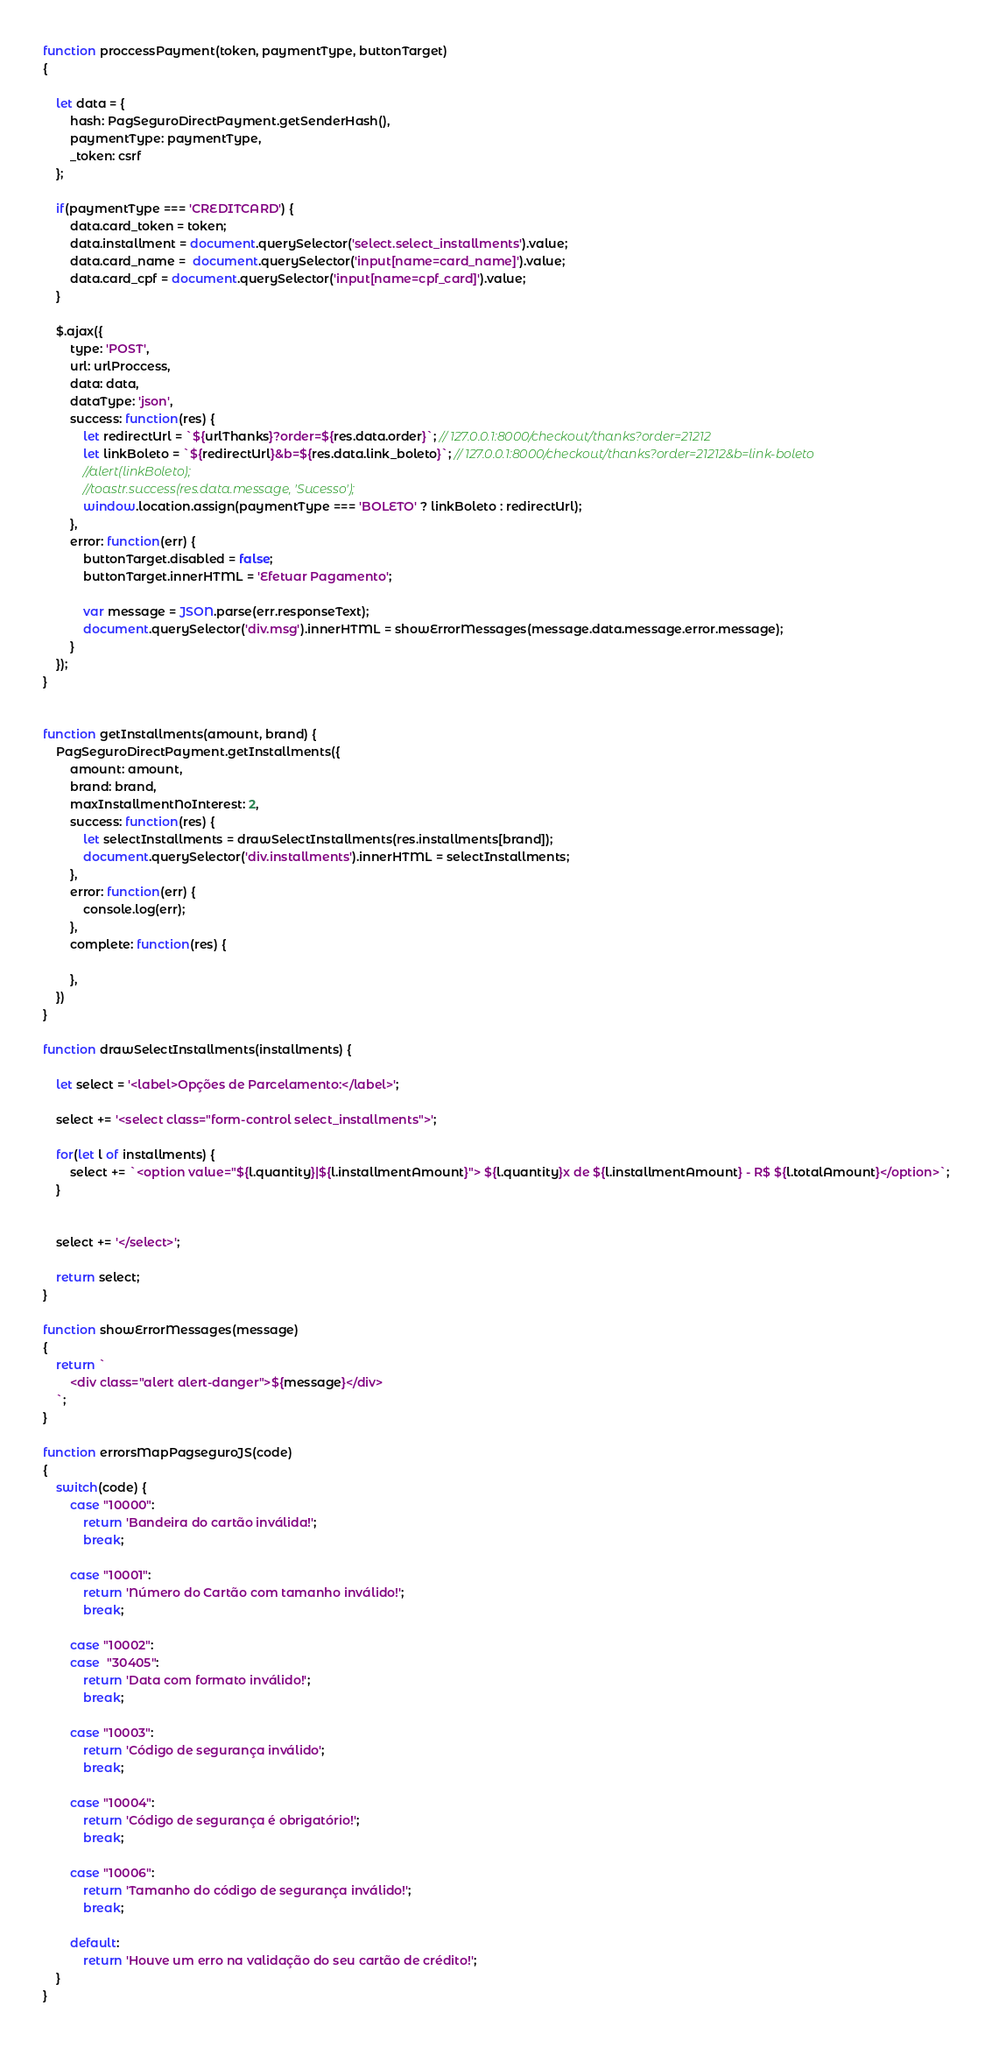Convert code to text. <code><loc_0><loc_0><loc_500><loc_500><_JavaScript_>function proccessPayment(token, paymentType, buttonTarget)
{
  
    let data = {
        hash: PagSeguroDirectPayment.getSenderHash(),
        paymentType: paymentType,
        _token: csrf
    };

    if(paymentType === 'CREDITCARD') {
        data.card_token = token;
        data.installment = document.querySelector('select.select_installments').value;
        data.card_name =  document.querySelector('input[name=card_name]').value;
        data.card_cpf = document.querySelector('input[name=cpf_card]').value;
    }

    $.ajax({
        type: 'POST',
        url: urlProccess,
        data: data,
        dataType: 'json',
        success: function(res) { 
            let redirectUrl = `${urlThanks}?order=${res.data.order}`; // 127.0.0.1:8000/checkout/thanks?order=21212
            let linkBoleto = `${redirectUrl}&b=${res.data.link_boleto}`; // 127.0.0.1:8000/checkout/thanks?order=21212&b=link-boleto
            //alert(linkBoleto);
            //toastr.success(res.data.message, 'Sucesso');
            window.location.assign(paymentType === 'BOLETO' ? linkBoleto : redirectUrl);
        },
        error: function(err) {
            buttonTarget.disabled = false;
            buttonTarget.innerHTML = 'Efetuar Pagamento';

            var message = JSON.parse(err.responseText);
            document.querySelector('div.msg').innerHTML = showErrorMessages(message.data.message.error.message);
        }
    });
}


function getInstallments(amount, brand) {
    PagSeguroDirectPayment.getInstallments({
        amount: amount,
        brand: brand,
        maxInstallmentNoInterest: 2,
        success: function(res) {
            let selectInstallments = drawSelectInstallments(res.installments[brand]);
            document.querySelector('div.installments').innerHTML = selectInstallments;
        },
        error: function(err) {
            console.log(err);
        },
        complete: function(res) {

        },
    })
}

function drawSelectInstallments(installments) {
    
    let select = '<label>Opções de Parcelamento:</label>';

    select += '<select class="form-control select_installments">';

    for(let l of installments) {
        select += `<option value="${l.quantity}|${l.installmentAmount}"> ${l.quantity}x de ${l.installmentAmount} - R$ ${l.totalAmount}</option>`;
    }


    select += '</select>';

    return select;
}

function showErrorMessages(message)
{
    return `
        <div class="alert alert-danger">${message}</div>
    `;
}

function errorsMapPagseguroJS(code)
{
    switch(code) {
        case "10000":
            return 'Bandeira do cartão inválida!';
            break;

        case "10001":
            return 'Número do Cartão com tamanho inválido!';
            break;

        case "10002":
        case  "30405":
            return 'Data com formato inválido!';
            break;

        case "10003":
            return 'Código de segurança inválido';
            break;

        case "10004":
            return 'Código de segurança é obrigatório!';
            break;

        case "10006":
            return 'Tamanho do código de segurança inválido!';
            break;

        default:
            return 'Houve um erro na validação do seu cartão de crédito!';
    }
}</code> 